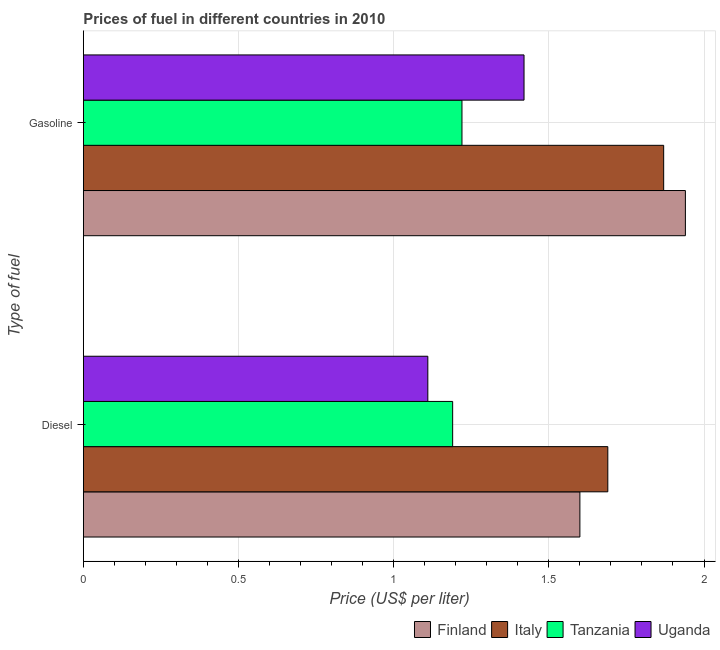How many different coloured bars are there?
Keep it short and to the point. 4. How many groups of bars are there?
Your response must be concise. 2. How many bars are there on the 1st tick from the top?
Make the answer very short. 4. How many bars are there on the 2nd tick from the bottom?
Provide a short and direct response. 4. What is the label of the 1st group of bars from the top?
Provide a succinct answer. Gasoline. What is the diesel price in Uganda?
Your response must be concise. 1.11. Across all countries, what is the maximum diesel price?
Ensure brevity in your answer.  1.69. Across all countries, what is the minimum gasoline price?
Offer a very short reply. 1.22. In which country was the gasoline price minimum?
Give a very brief answer. Tanzania. What is the total diesel price in the graph?
Provide a succinct answer. 5.59. What is the difference between the diesel price in Finland and that in Uganda?
Provide a succinct answer. 0.49. What is the difference between the gasoline price in Tanzania and the diesel price in Uganda?
Keep it short and to the point. 0.11. What is the average diesel price per country?
Give a very brief answer. 1.4. What is the difference between the diesel price and gasoline price in Uganda?
Your answer should be compact. -0.31. In how many countries, is the diesel price greater than 0.1 US$ per litre?
Offer a terse response. 4. What is the ratio of the diesel price in Finland to that in Tanzania?
Your response must be concise. 1.34. In how many countries, is the diesel price greater than the average diesel price taken over all countries?
Your answer should be compact. 2. What does the 1st bar from the top in Diesel represents?
Keep it short and to the point. Uganda. How many bars are there?
Provide a succinct answer. 8. Are the values on the major ticks of X-axis written in scientific E-notation?
Keep it short and to the point. No. Does the graph contain any zero values?
Give a very brief answer. No. Where does the legend appear in the graph?
Your answer should be compact. Bottom right. What is the title of the graph?
Make the answer very short. Prices of fuel in different countries in 2010. What is the label or title of the X-axis?
Provide a succinct answer. Price (US$ per liter). What is the label or title of the Y-axis?
Give a very brief answer. Type of fuel. What is the Price (US$ per liter) of Finland in Diesel?
Your answer should be compact. 1.6. What is the Price (US$ per liter) of Italy in Diesel?
Your answer should be very brief. 1.69. What is the Price (US$ per liter) in Tanzania in Diesel?
Give a very brief answer. 1.19. What is the Price (US$ per liter) in Uganda in Diesel?
Provide a succinct answer. 1.11. What is the Price (US$ per liter) in Finland in Gasoline?
Offer a very short reply. 1.94. What is the Price (US$ per liter) of Italy in Gasoline?
Offer a very short reply. 1.87. What is the Price (US$ per liter) in Tanzania in Gasoline?
Give a very brief answer. 1.22. What is the Price (US$ per liter) of Uganda in Gasoline?
Give a very brief answer. 1.42. Across all Type of fuel, what is the maximum Price (US$ per liter) of Finland?
Your response must be concise. 1.94. Across all Type of fuel, what is the maximum Price (US$ per liter) in Italy?
Offer a very short reply. 1.87. Across all Type of fuel, what is the maximum Price (US$ per liter) in Tanzania?
Provide a succinct answer. 1.22. Across all Type of fuel, what is the maximum Price (US$ per liter) in Uganda?
Your answer should be compact. 1.42. Across all Type of fuel, what is the minimum Price (US$ per liter) of Finland?
Make the answer very short. 1.6. Across all Type of fuel, what is the minimum Price (US$ per liter) of Italy?
Keep it short and to the point. 1.69. Across all Type of fuel, what is the minimum Price (US$ per liter) of Tanzania?
Provide a short and direct response. 1.19. Across all Type of fuel, what is the minimum Price (US$ per liter) of Uganda?
Your answer should be compact. 1.11. What is the total Price (US$ per liter) in Finland in the graph?
Provide a succinct answer. 3.54. What is the total Price (US$ per liter) of Italy in the graph?
Ensure brevity in your answer.  3.56. What is the total Price (US$ per liter) in Tanzania in the graph?
Your answer should be compact. 2.41. What is the total Price (US$ per liter) in Uganda in the graph?
Your response must be concise. 2.53. What is the difference between the Price (US$ per liter) in Finland in Diesel and that in Gasoline?
Provide a succinct answer. -0.34. What is the difference between the Price (US$ per liter) in Italy in Diesel and that in Gasoline?
Your answer should be very brief. -0.18. What is the difference between the Price (US$ per liter) in Tanzania in Diesel and that in Gasoline?
Make the answer very short. -0.03. What is the difference between the Price (US$ per liter) in Uganda in Diesel and that in Gasoline?
Your answer should be compact. -0.31. What is the difference between the Price (US$ per liter) in Finland in Diesel and the Price (US$ per liter) in Italy in Gasoline?
Make the answer very short. -0.27. What is the difference between the Price (US$ per liter) of Finland in Diesel and the Price (US$ per liter) of Tanzania in Gasoline?
Provide a succinct answer. 0.38. What is the difference between the Price (US$ per liter) of Finland in Diesel and the Price (US$ per liter) of Uganda in Gasoline?
Ensure brevity in your answer.  0.18. What is the difference between the Price (US$ per liter) in Italy in Diesel and the Price (US$ per liter) in Tanzania in Gasoline?
Your answer should be compact. 0.47. What is the difference between the Price (US$ per liter) in Italy in Diesel and the Price (US$ per liter) in Uganda in Gasoline?
Ensure brevity in your answer.  0.27. What is the difference between the Price (US$ per liter) of Tanzania in Diesel and the Price (US$ per liter) of Uganda in Gasoline?
Make the answer very short. -0.23. What is the average Price (US$ per liter) of Finland per Type of fuel?
Ensure brevity in your answer.  1.77. What is the average Price (US$ per liter) in Italy per Type of fuel?
Your response must be concise. 1.78. What is the average Price (US$ per liter) of Tanzania per Type of fuel?
Your answer should be compact. 1.21. What is the average Price (US$ per liter) of Uganda per Type of fuel?
Offer a terse response. 1.26. What is the difference between the Price (US$ per liter) of Finland and Price (US$ per liter) of Italy in Diesel?
Your answer should be compact. -0.09. What is the difference between the Price (US$ per liter) of Finland and Price (US$ per liter) of Tanzania in Diesel?
Ensure brevity in your answer.  0.41. What is the difference between the Price (US$ per liter) in Finland and Price (US$ per liter) in Uganda in Diesel?
Keep it short and to the point. 0.49. What is the difference between the Price (US$ per liter) of Italy and Price (US$ per liter) of Uganda in Diesel?
Make the answer very short. 0.58. What is the difference between the Price (US$ per liter) in Tanzania and Price (US$ per liter) in Uganda in Diesel?
Your answer should be compact. 0.08. What is the difference between the Price (US$ per liter) of Finland and Price (US$ per liter) of Italy in Gasoline?
Offer a very short reply. 0.07. What is the difference between the Price (US$ per liter) in Finland and Price (US$ per liter) in Tanzania in Gasoline?
Keep it short and to the point. 0.72. What is the difference between the Price (US$ per liter) of Finland and Price (US$ per liter) of Uganda in Gasoline?
Give a very brief answer. 0.52. What is the difference between the Price (US$ per liter) of Italy and Price (US$ per liter) of Tanzania in Gasoline?
Provide a short and direct response. 0.65. What is the difference between the Price (US$ per liter) of Italy and Price (US$ per liter) of Uganda in Gasoline?
Offer a very short reply. 0.45. What is the difference between the Price (US$ per liter) of Tanzania and Price (US$ per liter) of Uganda in Gasoline?
Give a very brief answer. -0.2. What is the ratio of the Price (US$ per liter) of Finland in Diesel to that in Gasoline?
Make the answer very short. 0.82. What is the ratio of the Price (US$ per liter) of Italy in Diesel to that in Gasoline?
Your answer should be very brief. 0.9. What is the ratio of the Price (US$ per liter) of Tanzania in Diesel to that in Gasoline?
Ensure brevity in your answer.  0.98. What is the ratio of the Price (US$ per liter) in Uganda in Diesel to that in Gasoline?
Provide a succinct answer. 0.78. What is the difference between the highest and the second highest Price (US$ per liter) of Finland?
Offer a terse response. 0.34. What is the difference between the highest and the second highest Price (US$ per liter) of Italy?
Give a very brief answer. 0.18. What is the difference between the highest and the second highest Price (US$ per liter) of Tanzania?
Keep it short and to the point. 0.03. What is the difference between the highest and the second highest Price (US$ per liter) in Uganda?
Give a very brief answer. 0.31. What is the difference between the highest and the lowest Price (US$ per liter) in Finland?
Your answer should be compact. 0.34. What is the difference between the highest and the lowest Price (US$ per liter) in Italy?
Make the answer very short. 0.18. What is the difference between the highest and the lowest Price (US$ per liter) in Uganda?
Provide a succinct answer. 0.31. 